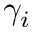<formula> <loc_0><loc_0><loc_500><loc_500>\gamma _ { i }</formula> 